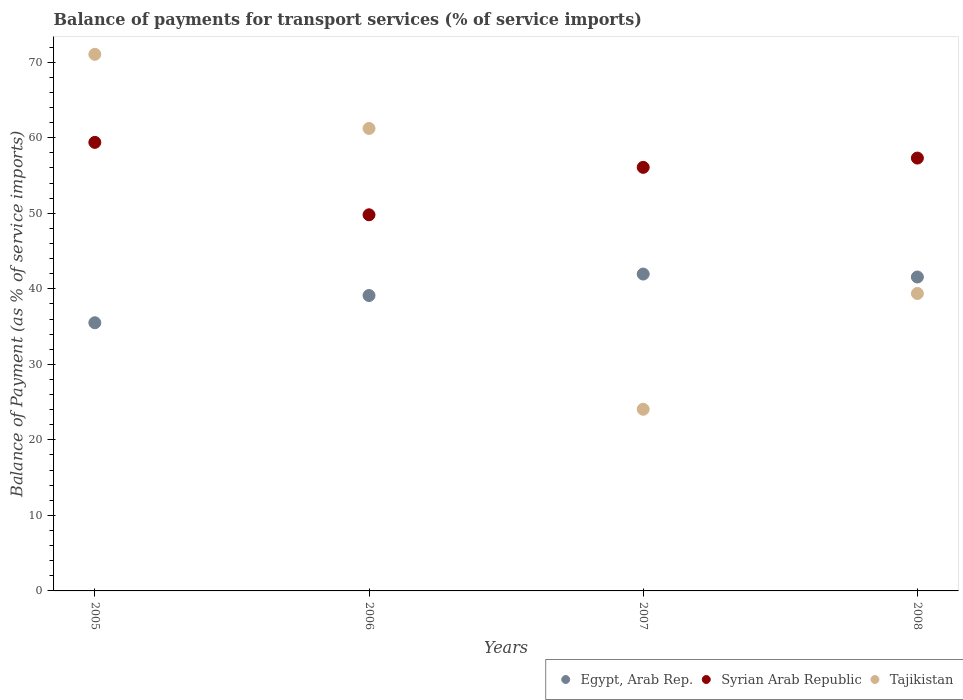How many different coloured dotlines are there?
Your response must be concise. 3. Is the number of dotlines equal to the number of legend labels?
Your answer should be very brief. Yes. What is the balance of payments for transport services in Syrian Arab Republic in 2006?
Provide a short and direct response. 49.8. Across all years, what is the maximum balance of payments for transport services in Syrian Arab Republic?
Give a very brief answer. 59.39. Across all years, what is the minimum balance of payments for transport services in Syrian Arab Republic?
Your answer should be compact. 49.8. What is the total balance of payments for transport services in Tajikistan in the graph?
Provide a short and direct response. 195.72. What is the difference between the balance of payments for transport services in Syrian Arab Republic in 2006 and that in 2007?
Your response must be concise. -6.28. What is the difference between the balance of payments for transport services in Tajikistan in 2006 and the balance of payments for transport services in Egypt, Arab Rep. in 2007?
Offer a very short reply. 19.28. What is the average balance of payments for transport services in Tajikistan per year?
Keep it short and to the point. 48.93. In the year 2005, what is the difference between the balance of payments for transport services in Egypt, Arab Rep. and balance of payments for transport services in Tajikistan?
Your response must be concise. -35.54. What is the ratio of the balance of payments for transport services in Tajikistan in 2005 to that in 2006?
Offer a terse response. 1.16. Is the difference between the balance of payments for transport services in Egypt, Arab Rep. in 2005 and 2006 greater than the difference between the balance of payments for transport services in Tajikistan in 2005 and 2006?
Ensure brevity in your answer.  No. What is the difference between the highest and the second highest balance of payments for transport services in Egypt, Arab Rep.?
Your response must be concise. 0.39. What is the difference between the highest and the lowest balance of payments for transport services in Syrian Arab Republic?
Keep it short and to the point. 9.59. In how many years, is the balance of payments for transport services in Egypt, Arab Rep. greater than the average balance of payments for transport services in Egypt, Arab Rep. taken over all years?
Your answer should be compact. 2. Does the balance of payments for transport services in Egypt, Arab Rep. monotonically increase over the years?
Give a very brief answer. No. How many years are there in the graph?
Provide a succinct answer. 4. Does the graph contain any zero values?
Offer a very short reply. No. Does the graph contain grids?
Your response must be concise. No. How many legend labels are there?
Your response must be concise. 3. What is the title of the graph?
Offer a very short reply. Balance of payments for transport services (% of service imports). Does "Germany" appear as one of the legend labels in the graph?
Your answer should be very brief. No. What is the label or title of the Y-axis?
Provide a short and direct response. Balance of Payment (as % of service imports). What is the Balance of Payment (as % of service imports) in Egypt, Arab Rep. in 2005?
Your answer should be compact. 35.51. What is the Balance of Payment (as % of service imports) of Syrian Arab Republic in 2005?
Ensure brevity in your answer.  59.39. What is the Balance of Payment (as % of service imports) in Tajikistan in 2005?
Give a very brief answer. 71.05. What is the Balance of Payment (as % of service imports) in Egypt, Arab Rep. in 2006?
Your answer should be compact. 39.11. What is the Balance of Payment (as % of service imports) of Syrian Arab Republic in 2006?
Keep it short and to the point. 49.8. What is the Balance of Payment (as % of service imports) in Tajikistan in 2006?
Your answer should be compact. 61.23. What is the Balance of Payment (as % of service imports) of Egypt, Arab Rep. in 2007?
Your answer should be very brief. 41.96. What is the Balance of Payment (as % of service imports) in Syrian Arab Republic in 2007?
Make the answer very short. 56.08. What is the Balance of Payment (as % of service imports) of Tajikistan in 2007?
Offer a terse response. 24.05. What is the Balance of Payment (as % of service imports) in Egypt, Arab Rep. in 2008?
Your answer should be very brief. 41.56. What is the Balance of Payment (as % of service imports) in Syrian Arab Republic in 2008?
Make the answer very short. 57.31. What is the Balance of Payment (as % of service imports) of Tajikistan in 2008?
Your response must be concise. 39.38. Across all years, what is the maximum Balance of Payment (as % of service imports) in Egypt, Arab Rep.?
Your response must be concise. 41.96. Across all years, what is the maximum Balance of Payment (as % of service imports) of Syrian Arab Republic?
Make the answer very short. 59.39. Across all years, what is the maximum Balance of Payment (as % of service imports) in Tajikistan?
Provide a short and direct response. 71.05. Across all years, what is the minimum Balance of Payment (as % of service imports) in Egypt, Arab Rep.?
Give a very brief answer. 35.51. Across all years, what is the minimum Balance of Payment (as % of service imports) in Syrian Arab Republic?
Make the answer very short. 49.8. Across all years, what is the minimum Balance of Payment (as % of service imports) of Tajikistan?
Offer a very short reply. 24.05. What is the total Balance of Payment (as % of service imports) of Egypt, Arab Rep. in the graph?
Make the answer very short. 158.14. What is the total Balance of Payment (as % of service imports) in Syrian Arab Republic in the graph?
Your answer should be compact. 222.59. What is the total Balance of Payment (as % of service imports) in Tajikistan in the graph?
Provide a short and direct response. 195.72. What is the difference between the Balance of Payment (as % of service imports) in Egypt, Arab Rep. in 2005 and that in 2006?
Provide a succinct answer. -3.6. What is the difference between the Balance of Payment (as % of service imports) of Syrian Arab Republic in 2005 and that in 2006?
Make the answer very short. 9.59. What is the difference between the Balance of Payment (as % of service imports) in Tajikistan in 2005 and that in 2006?
Keep it short and to the point. 9.82. What is the difference between the Balance of Payment (as % of service imports) of Egypt, Arab Rep. in 2005 and that in 2007?
Make the answer very short. -6.45. What is the difference between the Balance of Payment (as % of service imports) of Syrian Arab Republic in 2005 and that in 2007?
Provide a succinct answer. 3.31. What is the difference between the Balance of Payment (as % of service imports) in Tajikistan in 2005 and that in 2007?
Provide a short and direct response. 47. What is the difference between the Balance of Payment (as % of service imports) in Egypt, Arab Rep. in 2005 and that in 2008?
Give a very brief answer. -6.05. What is the difference between the Balance of Payment (as % of service imports) of Syrian Arab Republic in 2005 and that in 2008?
Offer a very short reply. 2.08. What is the difference between the Balance of Payment (as % of service imports) in Tajikistan in 2005 and that in 2008?
Your answer should be very brief. 31.67. What is the difference between the Balance of Payment (as % of service imports) of Egypt, Arab Rep. in 2006 and that in 2007?
Make the answer very short. -2.84. What is the difference between the Balance of Payment (as % of service imports) of Syrian Arab Republic in 2006 and that in 2007?
Offer a very short reply. -6.28. What is the difference between the Balance of Payment (as % of service imports) of Tajikistan in 2006 and that in 2007?
Provide a short and direct response. 37.18. What is the difference between the Balance of Payment (as % of service imports) of Egypt, Arab Rep. in 2006 and that in 2008?
Offer a terse response. -2.45. What is the difference between the Balance of Payment (as % of service imports) in Syrian Arab Republic in 2006 and that in 2008?
Ensure brevity in your answer.  -7.51. What is the difference between the Balance of Payment (as % of service imports) of Tajikistan in 2006 and that in 2008?
Keep it short and to the point. 21.85. What is the difference between the Balance of Payment (as % of service imports) of Egypt, Arab Rep. in 2007 and that in 2008?
Provide a succinct answer. 0.39. What is the difference between the Balance of Payment (as % of service imports) in Syrian Arab Republic in 2007 and that in 2008?
Your response must be concise. -1.23. What is the difference between the Balance of Payment (as % of service imports) of Tajikistan in 2007 and that in 2008?
Keep it short and to the point. -15.33. What is the difference between the Balance of Payment (as % of service imports) of Egypt, Arab Rep. in 2005 and the Balance of Payment (as % of service imports) of Syrian Arab Republic in 2006?
Provide a short and direct response. -14.29. What is the difference between the Balance of Payment (as % of service imports) of Egypt, Arab Rep. in 2005 and the Balance of Payment (as % of service imports) of Tajikistan in 2006?
Give a very brief answer. -25.72. What is the difference between the Balance of Payment (as % of service imports) of Syrian Arab Republic in 2005 and the Balance of Payment (as % of service imports) of Tajikistan in 2006?
Make the answer very short. -1.84. What is the difference between the Balance of Payment (as % of service imports) of Egypt, Arab Rep. in 2005 and the Balance of Payment (as % of service imports) of Syrian Arab Republic in 2007?
Offer a terse response. -20.58. What is the difference between the Balance of Payment (as % of service imports) of Egypt, Arab Rep. in 2005 and the Balance of Payment (as % of service imports) of Tajikistan in 2007?
Give a very brief answer. 11.46. What is the difference between the Balance of Payment (as % of service imports) in Syrian Arab Republic in 2005 and the Balance of Payment (as % of service imports) in Tajikistan in 2007?
Your answer should be compact. 35.34. What is the difference between the Balance of Payment (as % of service imports) in Egypt, Arab Rep. in 2005 and the Balance of Payment (as % of service imports) in Syrian Arab Republic in 2008?
Ensure brevity in your answer.  -21.8. What is the difference between the Balance of Payment (as % of service imports) of Egypt, Arab Rep. in 2005 and the Balance of Payment (as % of service imports) of Tajikistan in 2008?
Offer a terse response. -3.87. What is the difference between the Balance of Payment (as % of service imports) in Syrian Arab Republic in 2005 and the Balance of Payment (as % of service imports) in Tajikistan in 2008?
Keep it short and to the point. 20.01. What is the difference between the Balance of Payment (as % of service imports) in Egypt, Arab Rep. in 2006 and the Balance of Payment (as % of service imports) in Syrian Arab Republic in 2007?
Ensure brevity in your answer.  -16.97. What is the difference between the Balance of Payment (as % of service imports) of Egypt, Arab Rep. in 2006 and the Balance of Payment (as % of service imports) of Tajikistan in 2007?
Give a very brief answer. 15.06. What is the difference between the Balance of Payment (as % of service imports) of Syrian Arab Republic in 2006 and the Balance of Payment (as % of service imports) of Tajikistan in 2007?
Provide a short and direct response. 25.75. What is the difference between the Balance of Payment (as % of service imports) in Egypt, Arab Rep. in 2006 and the Balance of Payment (as % of service imports) in Syrian Arab Republic in 2008?
Ensure brevity in your answer.  -18.2. What is the difference between the Balance of Payment (as % of service imports) of Egypt, Arab Rep. in 2006 and the Balance of Payment (as % of service imports) of Tajikistan in 2008?
Your answer should be compact. -0.27. What is the difference between the Balance of Payment (as % of service imports) in Syrian Arab Republic in 2006 and the Balance of Payment (as % of service imports) in Tajikistan in 2008?
Keep it short and to the point. 10.42. What is the difference between the Balance of Payment (as % of service imports) of Egypt, Arab Rep. in 2007 and the Balance of Payment (as % of service imports) of Syrian Arab Republic in 2008?
Keep it short and to the point. -15.36. What is the difference between the Balance of Payment (as % of service imports) in Egypt, Arab Rep. in 2007 and the Balance of Payment (as % of service imports) in Tajikistan in 2008?
Your response must be concise. 2.57. What is the difference between the Balance of Payment (as % of service imports) in Syrian Arab Republic in 2007 and the Balance of Payment (as % of service imports) in Tajikistan in 2008?
Your answer should be very brief. 16.7. What is the average Balance of Payment (as % of service imports) of Egypt, Arab Rep. per year?
Offer a very short reply. 39.54. What is the average Balance of Payment (as % of service imports) in Syrian Arab Republic per year?
Keep it short and to the point. 55.65. What is the average Balance of Payment (as % of service imports) in Tajikistan per year?
Provide a short and direct response. 48.93. In the year 2005, what is the difference between the Balance of Payment (as % of service imports) in Egypt, Arab Rep. and Balance of Payment (as % of service imports) in Syrian Arab Republic?
Offer a very short reply. -23.88. In the year 2005, what is the difference between the Balance of Payment (as % of service imports) of Egypt, Arab Rep. and Balance of Payment (as % of service imports) of Tajikistan?
Make the answer very short. -35.54. In the year 2005, what is the difference between the Balance of Payment (as % of service imports) in Syrian Arab Republic and Balance of Payment (as % of service imports) in Tajikistan?
Provide a succinct answer. -11.66. In the year 2006, what is the difference between the Balance of Payment (as % of service imports) of Egypt, Arab Rep. and Balance of Payment (as % of service imports) of Syrian Arab Republic?
Ensure brevity in your answer.  -10.69. In the year 2006, what is the difference between the Balance of Payment (as % of service imports) of Egypt, Arab Rep. and Balance of Payment (as % of service imports) of Tajikistan?
Offer a very short reply. -22.12. In the year 2006, what is the difference between the Balance of Payment (as % of service imports) of Syrian Arab Republic and Balance of Payment (as % of service imports) of Tajikistan?
Your response must be concise. -11.43. In the year 2007, what is the difference between the Balance of Payment (as % of service imports) of Egypt, Arab Rep. and Balance of Payment (as % of service imports) of Syrian Arab Republic?
Make the answer very short. -14.13. In the year 2007, what is the difference between the Balance of Payment (as % of service imports) in Egypt, Arab Rep. and Balance of Payment (as % of service imports) in Tajikistan?
Your answer should be very brief. 17.9. In the year 2007, what is the difference between the Balance of Payment (as % of service imports) in Syrian Arab Republic and Balance of Payment (as % of service imports) in Tajikistan?
Provide a succinct answer. 32.03. In the year 2008, what is the difference between the Balance of Payment (as % of service imports) of Egypt, Arab Rep. and Balance of Payment (as % of service imports) of Syrian Arab Republic?
Your answer should be compact. -15.75. In the year 2008, what is the difference between the Balance of Payment (as % of service imports) in Egypt, Arab Rep. and Balance of Payment (as % of service imports) in Tajikistan?
Provide a succinct answer. 2.18. In the year 2008, what is the difference between the Balance of Payment (as % of service imports) of Syrian Arab Republic and Balance of Payment (as % of service imports) of Tajikistan?
Keep it short and to the point. 17.93. What is the ratio of the Balance of Payment (as % of service imports) of Egypt, Arab Rep. in 2005 to that in 2006?
Provide a short and direct response. 0.91. What is the ratio of the Balance of Payment (as % of service imports) of Syrian Arab Republic in 2005 to that in 2006?
Your answer should be compact. 1.19. What is the ratio of the Balance of Payment (as % of service imports) of Tajikistan in 2005 to that in 2006?
Provide a succinct answer. 1.16. What is the ratio of the Balance of Payment (as % of service imports) of Egypt, Arab Rep. in 2005 to that in 2007?
Ensure brevity in your answer.  0.85. What is the ratio of the Balance of Payment (as % of service imports) in Syrian Arab Republic in 2005 to that in 2007?
Give a very brief answer. 1.06. What is the ratio of the Balance of Payment (as % of service imports) in Tajikistan in 2005 to that in 2007?
Keep it short and to the point. 2.95. What is the ratio of the Balance of Payment (as % of service imports) in Egypt, Arab Rep. in 2005 to that in 2008?
Make the answer very short. 0.85. What is the ratio of the Balance of Payment (as % of service imports) in Syrian Arab Republic in 2005 to that in 2008?
Your answer should be compact. 1.04. What is the ratio of the Balance of Payment (as % of service imports) in Tajikistan in 2005 to that in 2008?
Make the answer very short. 1.8. What is the ratio of the Balance of Payment (as % of service imports) of Egypt, Arab Rep. in 2006 to that in 2007?
Your answer should be very brief. 0.93. What is the ratio of the Balance of Payment (as % of service imports) of Syrian Arab Republic in 2006 to that in 2007?
Your answer should be compact. 0.89. What is the ratio of the Balance of Payment (as % of service imports) of Tajikistan in 2006 to that in 2007?
Your answer should be compact. 2.55. What is the ratio of the Balance of Payment (as % of service imports) of Egypt, Arab Rep. in 2006 to that in 2008?
Your answer should be compact. 0.94. What is the ratio of the Balance of Payment (as % of service imports) in Syrian Arab Republic in 2006 to that in 2008?
Provide a succinct answer. 0.87. What is the ratio of the Balance of Payment (as % of service imports) of Tajikistan in 2006 to that in 2008?
Make the answer very short. 1.55. What is the ratio of the Balance of Payment (as % of service imports) in Egypt, Arab Rep. in 2007 to that in 2008?
Offer a very short reply. 1.01. What is the ratio of the Balance of Payment (as % of service imports) of Syrian Arab Republic in 2007 to that in 2008?
Keep it short and to the point. 0.98. What is the ratio of the Balance of Payment (as % of service imports) in Tajikistan in 2007 to that in 2008?
Your answer should be compact. 0.61. What is the difference between the highest and the second highest Balance of Payment (as % of service imports) of Egypt, Arab Rep.?
Give a very brief answer. 0.39. What is the difference between the highest and the second highest Balance of Payment (as % of service imports) of Syrian Arab Republic?
Make the answer very short. 2.08. What is the difference between the highest and the second highest Balance of Payment (as % of service imports) in Tajikistan?
Offer a terse response. 9.82. What is the difference between the highest and the lowest Balance of Payment (as % of service imports) in Egypt, Arab Rep.?
Keep it short and to the point. 6.45. What is the difference between the highest and the lowest Balance of Payment (as % of service imports) in Syrian Arab Republic?
Provide a succinct answer. 9.59. What is the difference between the highest and the lowest Balance of Payment (as % of service imports) in Tajikistan?
Offer a terse response. 47. 